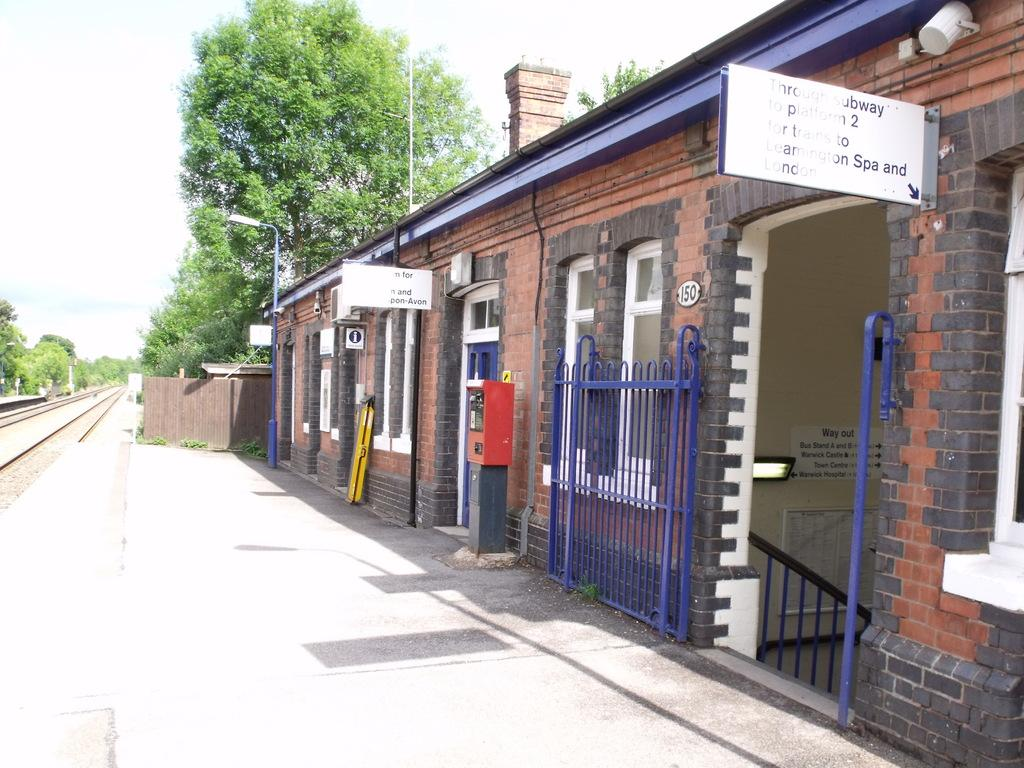What type of structures can be seen in the image? There are walls, boards, a grille, railing, windows, and a door visible in the image. Are there any decorative elements in the image? Yes, there are posters in the image. What type of lighting is present in the image? There is a light and a light pole in the image. What type of transportation infrastructure is visible in the image? There are train tracks in the image. What other objects can be seen in the image? There are objects in the image, but their specific nature is not mentioned in the provided facts. How does the mitten help the train tracks in the image? There is no mitten present in the image, so it cannot help the train tracks. What type of burn can be seen on the light pole in the image? There is no burn present on the light pole in the image. 